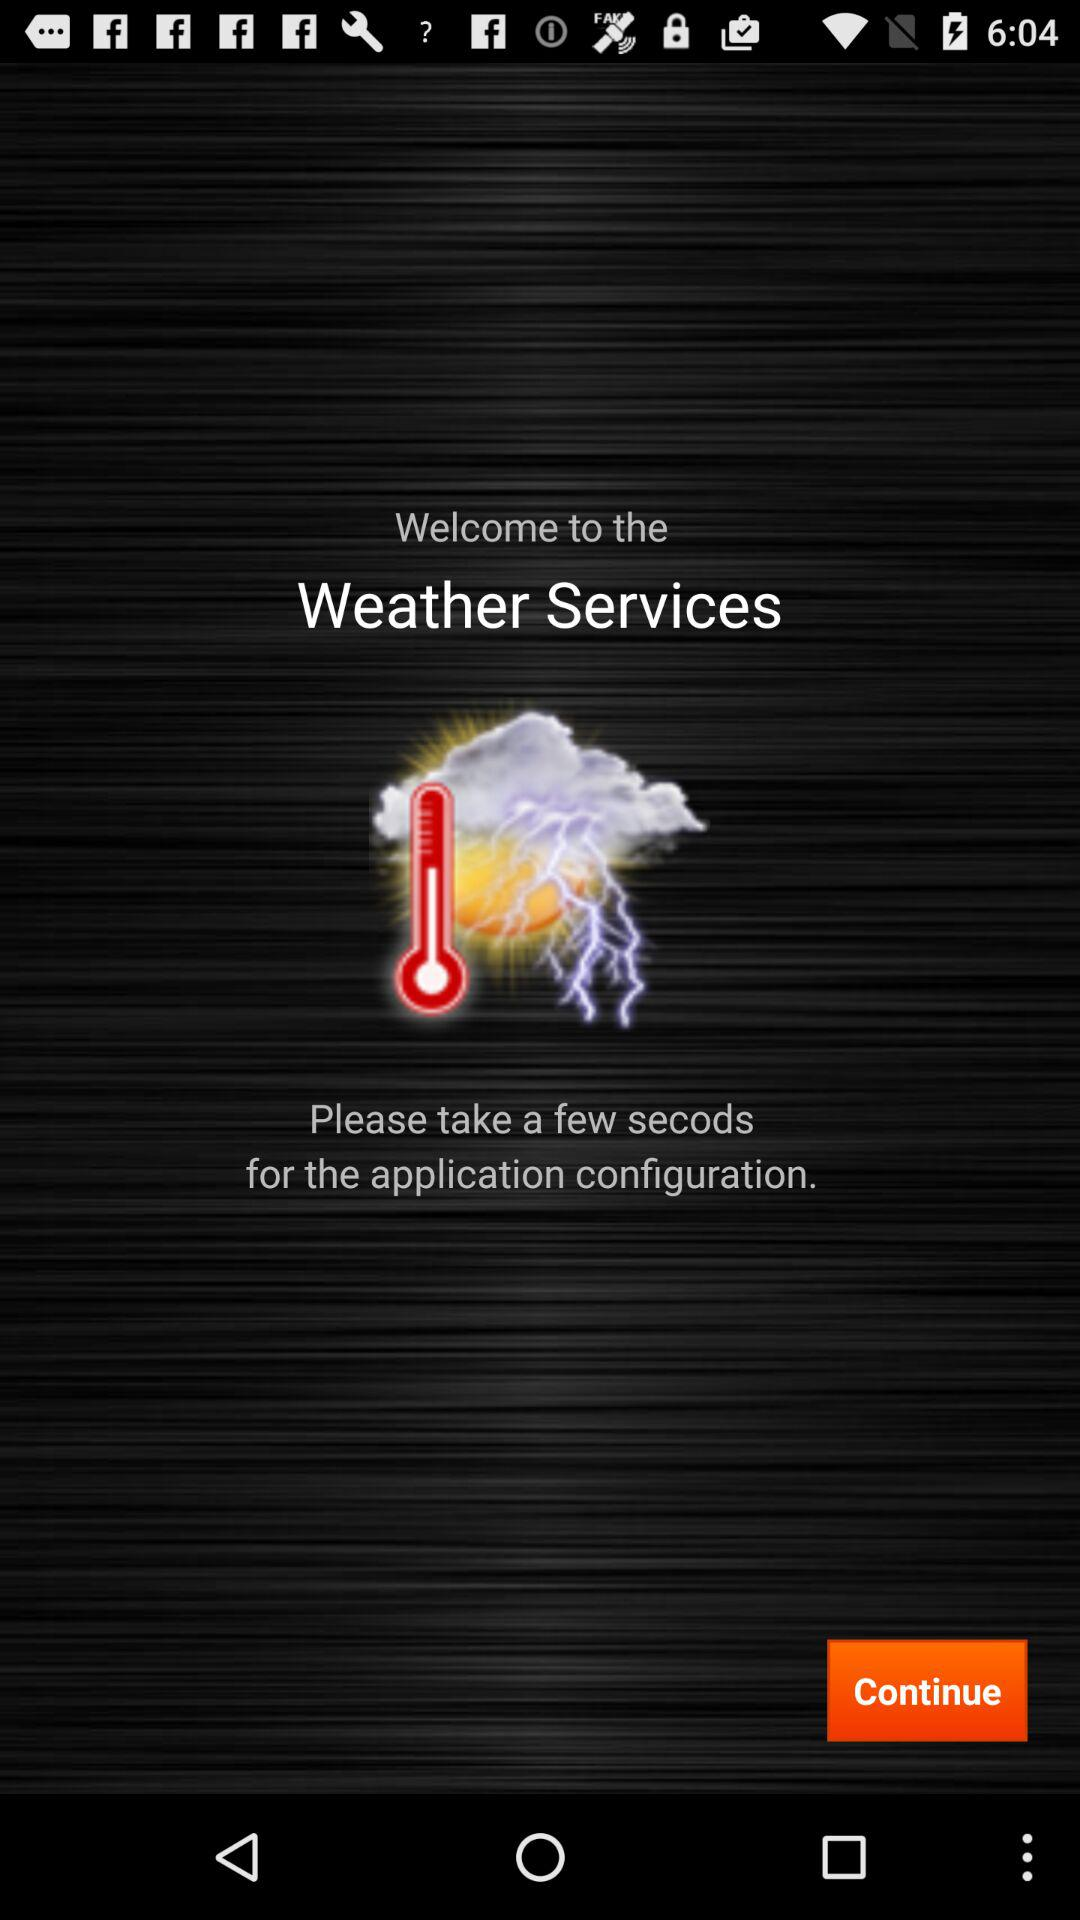What is the name of the application? The application is "Weather Services". 